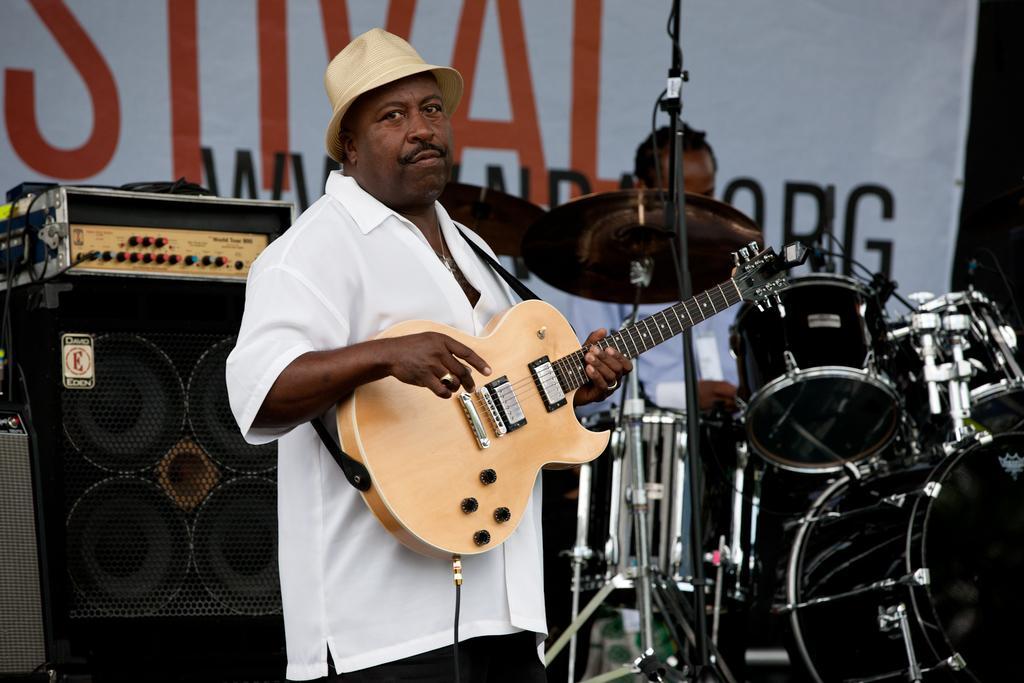Describe this image in one or two sentences. There is a person in white color shirt wearing a cap, holding and playing guitar. In the background, there are drums, speaker, hoarding, and a person sitting and playing drums. 